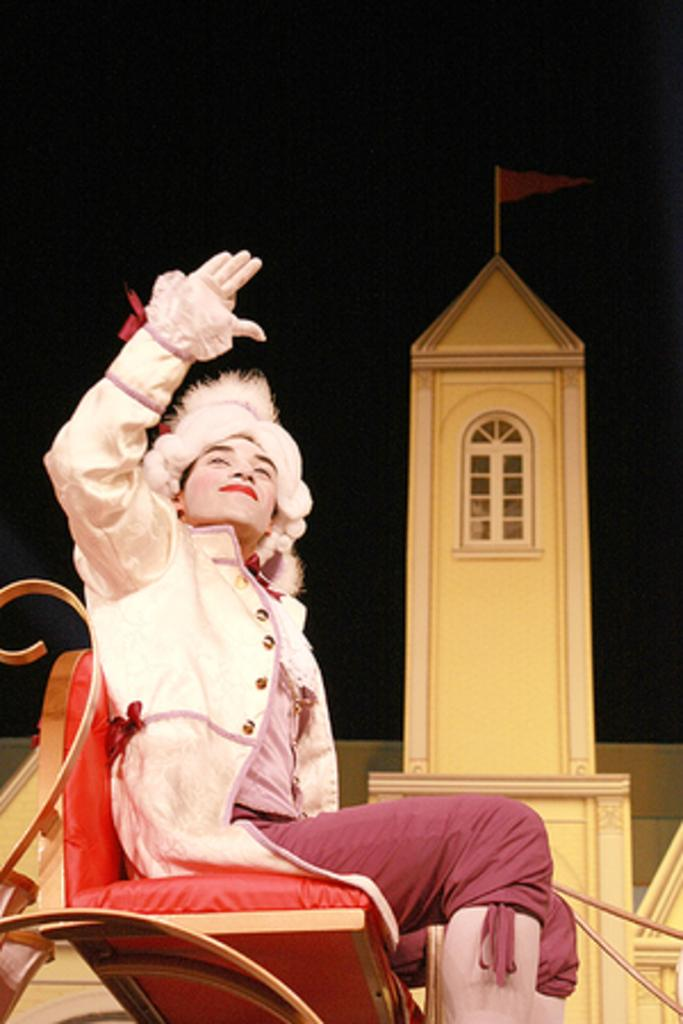What is the person in the image doing? The person is sitting on a chair in the image. What can be seen in the background of the image? There is a tower visible in the image. What is on top of the tower? There is a flag on top of the tower. Where is the hydrant located in the image? There is no hydrant present in the image. What type of engine is powering the tower in the image? There is no engine present in the image, as towers do not require engines for operation. 